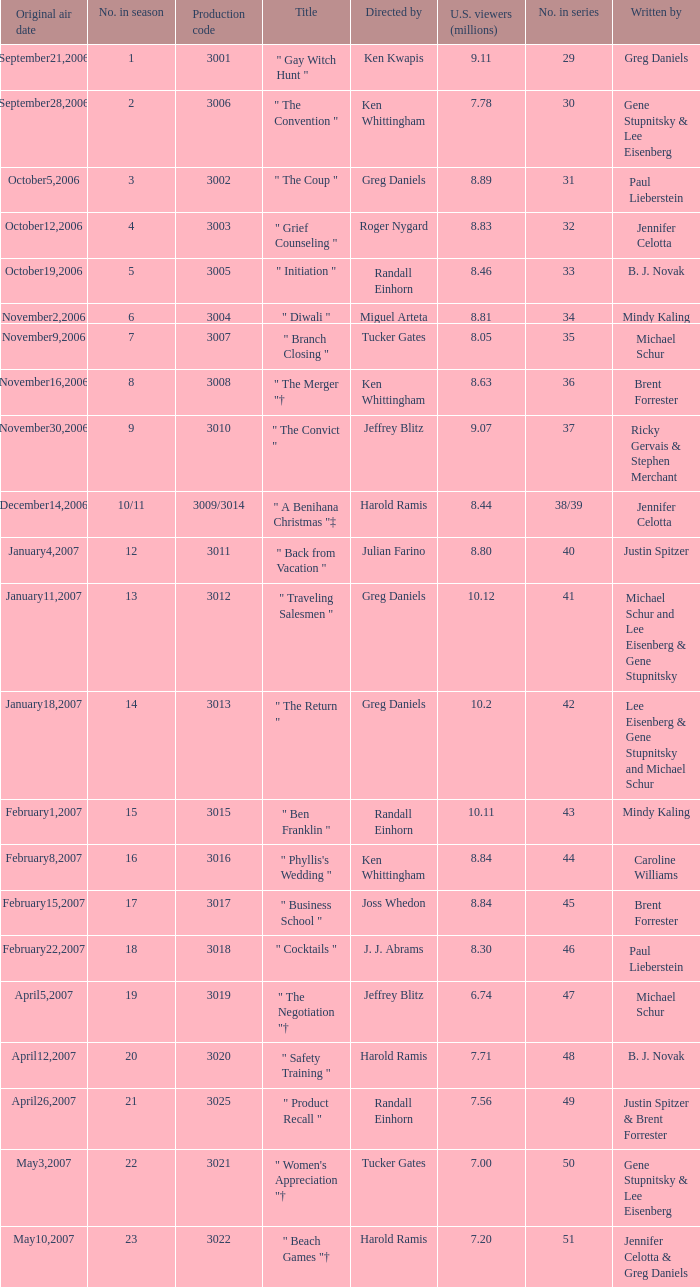Name the number of original air date for when the number in season is 10/11 1.0. 